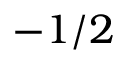<formula> <loc_0><loc_0><loc_500><loc_500>- 1 / 2</formula> 